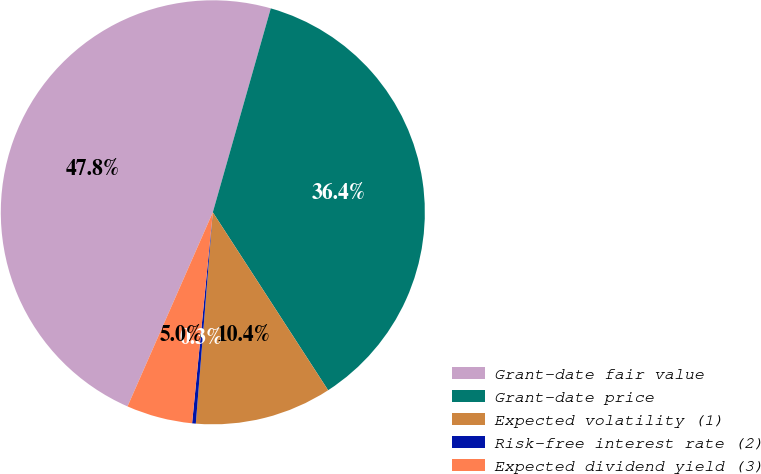<chart> <loc_0><loc_0><loc_500><loc_500><pie_chart><fcel>Grant-date fair value<fcel>Grant-date price<fcel>Expected volatility (1)<fcel>Risk-free interest rate (2)<fcel>Expected dividend yield (3)<nl><fcel>47.82%<fcel>36.44%<fcel>10.43%<fcel>0.28%<fcel>5.03%<nl></chart> 